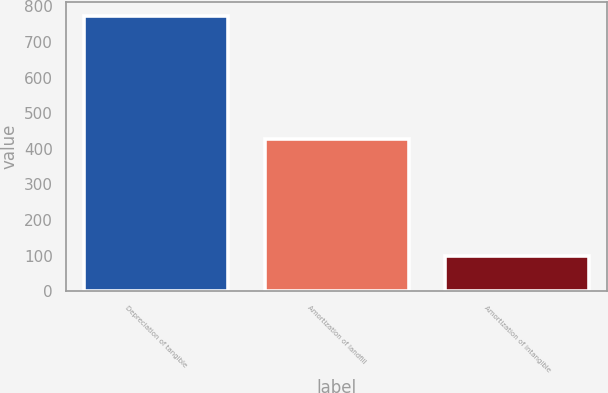<chart> <loc_0><loc_0><loc_500><loc_500><bar_chart><fcel>Depreciation of tangible<fcel>Amortization of landfill<fcel>Amortization of intangible<nl><fcel>773<fcel>428<fcel>100<nl></chart> 